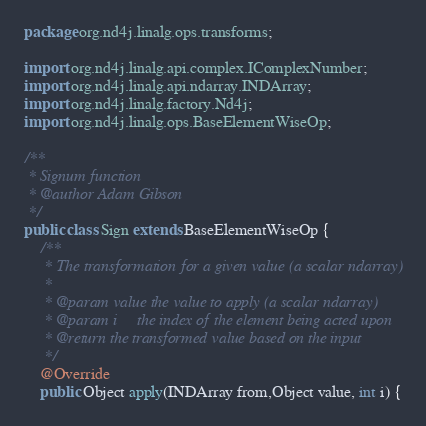<code> <loc_0><loc_0><loc_500><loc_500><_Java_>package org.nd4j.linalg.ops.transforms;

import org.nd4j.linalg.api.complex.IComplexNumber;
import org.nd4j.linalg.api.ndarray.INDArray;
import org.nd4j.linalg.factory.Nd4j;
import org.nd4j.linalg.ops.BaseElementWiseOp;

/**
 * Signum function
 * @author Adam Gibson
 */
public class Sign extends BaseElementWiseOp {
    /**
     * The transformation for a given value (a scalar ndarray)
     *
     * @param value the value to apply (a scalar ndarray)
     * @param i     the index of the element being acted upon
     * @return the transformed value based on the input
     */
    @Override
    public Object apply(INDArray from,Object value, int i) {</code> 